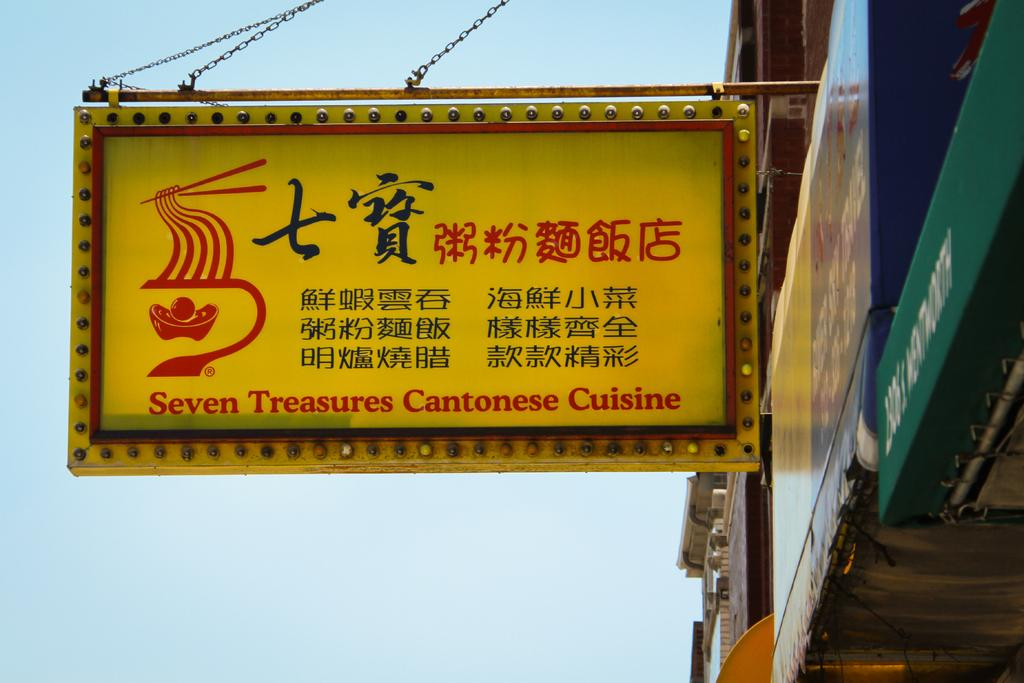<image>
Render a clear and concise summary of the photo. A large yellow sign for Seven Treasures Cantonese Cuisine. 